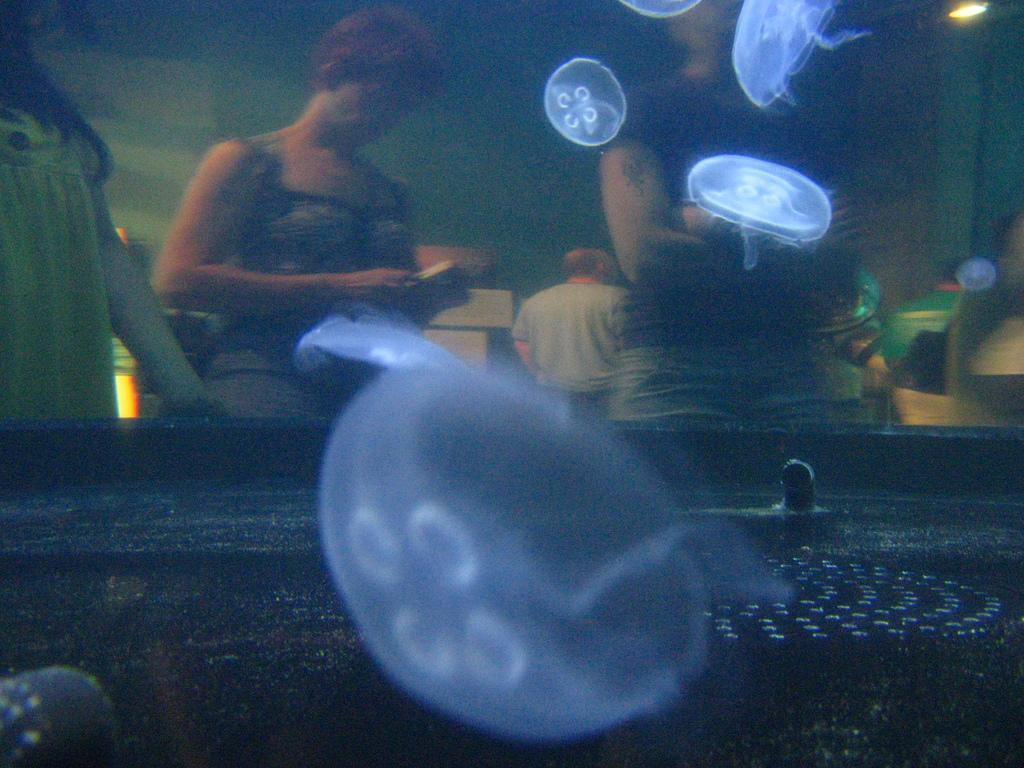Please provide a concise description of this image. In the foreground of this image, there are jellyfishes under the water and through the glass there are persons standing, a wall and few objects. 